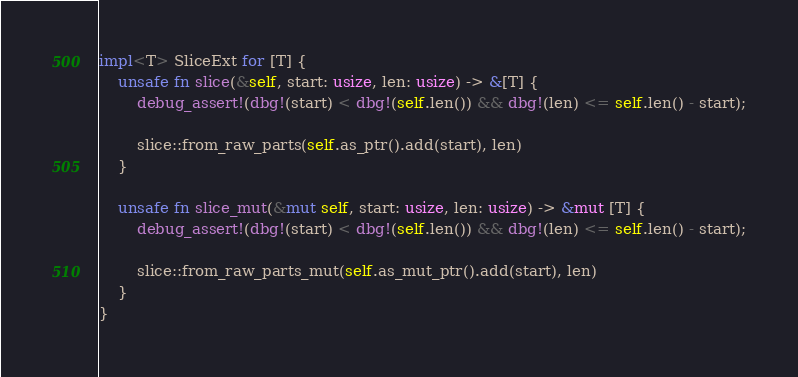Convert code to text. <code><loc_0><loc_0><loc_500><loc_500><_Rust_>impl<T> SliceExt for [T] {
    unsafe fn slice(&self, start: usize, len: usize) -> &[T] {
        debug_assert!(dbg!(start) < dbg!(self.len()) && dbg!(len) <= self.len() - start);

        slice::from_raw_parts(self.as_ptr().add(start), len)
    }

    unsafe fn slice_mut(&mut self, start: usize, len: usize) -> &mut [T] {
        debug_assert!(dbg!(start) < dbg!(self.len()) && dbg!(len) <= self.len() - start);

        slice::from_raw_parts_mut(self.as_mut_ptr().add(start), len)
    }
}
</code> 